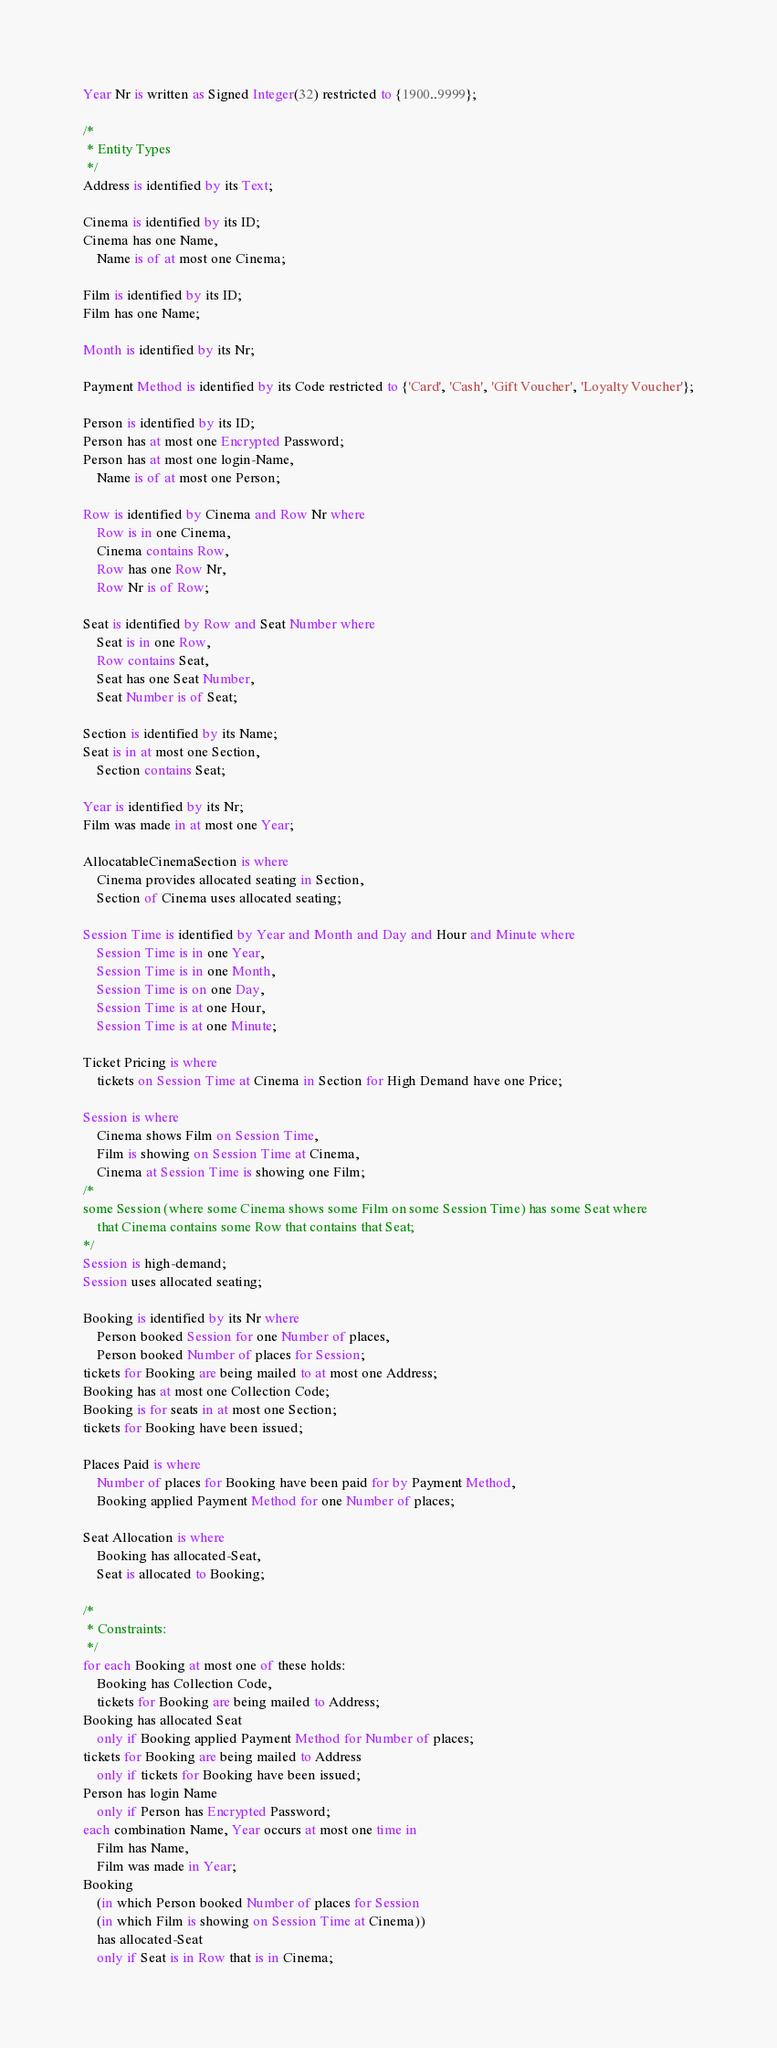<code> <loc_0><loc_0><loc_500><loc_500><_SQL_>Year Nr is written as Signed Integer(32) restricted to {1900..9999};

/*
 * Entity Types
 */
Address is identified by its Text;

Cinema is identified by its ID;
Cinema has one Name,
	Name is of at most one Cinema;

Film is identified by its ID;
Film has one Name;

Month is identified by its Nr;

Payment Method is identified by its Code restricted to {'Card', 'Cash', 'Gift Voucher', 'Loyalty Voucher'};

Person is identified by its ID;
Person has at most one Encrypted Password;
Person has at most one login-Name,
	Name is of at most one Person;

Row is identified by Cinema and Row Nr where
	Row is in one Cinema,
	Cinema contains Row,
	Row has one Row Nr,
	Row Nr is of Row;

Seat is identified by Row and Seat Number where
	Seat is in one Row,
	Row contains Seat,
	Seat has one Seat Number,
	Seat Number is of Seat;

Section is identified by its Name;
Seat is in at most one Section,
	Section contains Seat;

Year is identified by its Nr;
Film was made in at most one Year;

AllocatableCinemaSection is where
	Cinema provides allocated seating in Section,
	Section of Cinema uses allocated seating;

Session Time is identified by Year and Month and Day and Hour and Minute where
	Session Time is in one Year,
	Session Time is in one Month,
	Session Time is on one Day,
	Session Time is at one Hour,
	Session Time is at one Minute;

Ticket Pricing is where
	tickets on Session Time at Cinema in Section for High Demand have one Price;

Session is where
	Cinema shows Film on Session Time,
	Film is showing on Session Time at Cinema,
	Cinema at Session Time is showing one Film;
/*
some Session (where some Cinema shows some Film on some Session Time) has some Seat where
    that Cinema contains some Row that contains that Seat;
*/
Session is high-demand;
Session uses allocated seating;

Booking is identified by its Nr where
	Person booked Session for one Number of places,
	Person booked Number of places for Session;
tickets for Booking are being mailed to at most one Address;
Booking has at most one Collection Code;
Booking is for seats in at most one Section;
tickets for Booking have been issued;

Places Paid is where
	Number of places for Booking have been paid for by Payment Method,
	Booking applied Payment Method for one Number of places;

Seat Allocation is where
	Booking has allocated-Seat,
	Seat is allocated to Booking;

/*
 * Constraints:
 */
for each Booking at most one of these holds:
	Booking has Collection Code,
	tickets for Booking are being mailed to Address;
Booking has allocated Seat
	only if Booking applied Payment Method for Number of places;
tickets for Booking are being mailed to Address
	only if tickets for Booking have been issued;
Person has login Name
	only if Person has Encrypted Password;
each combination Name, Year occurs at most one time in
	Film has Name,
	Film was made in Year;
Booking
    (in which Person booked Number of places for Session
	(in which Film is showing on Session Time at Cinema))
    has allocated-Seat
    only if Seat is in Row that is in Cinema;
</code> 